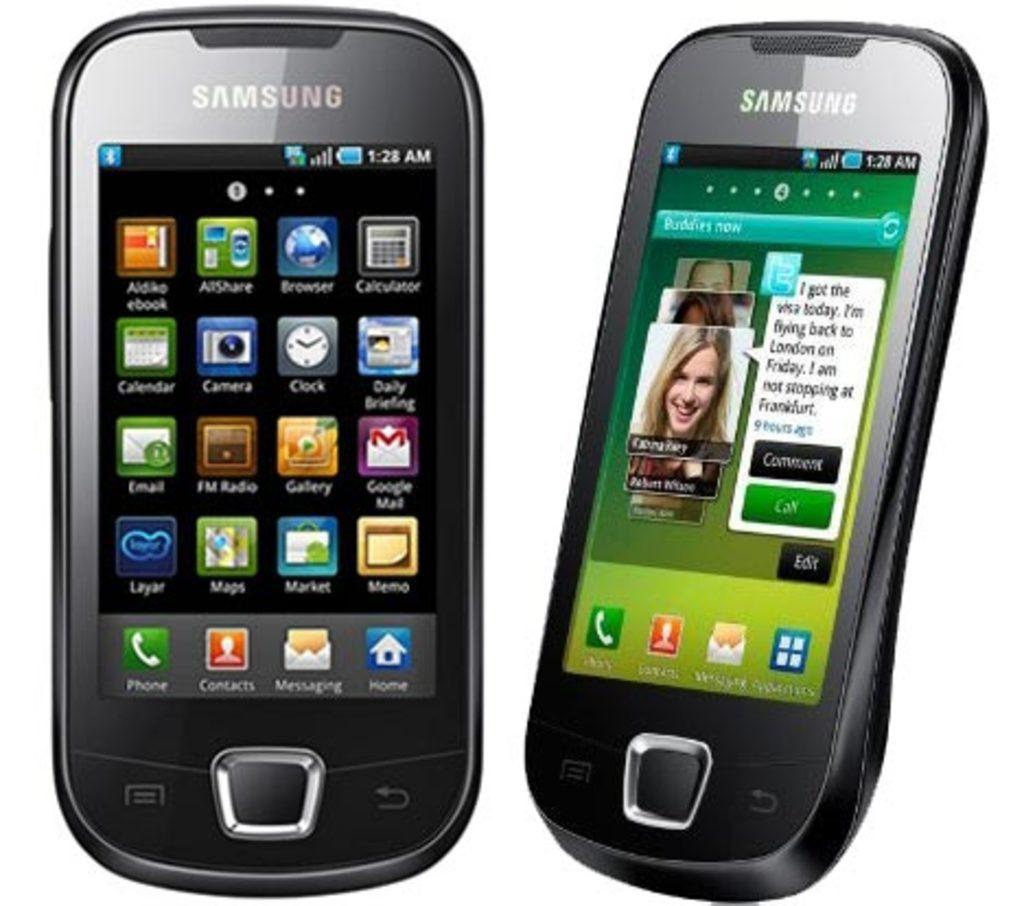<image>
Provide a brief description of the given image. two Samsung cell phones open to icon screens like Buddies Now 